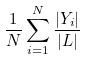Convert formula to latex. <formula><loc_0><loc_0><loc_500><loc_500>\frac { 1 } { N } \sum _ { i = 1 } ^ { N } \frac { | Y _ { i } | } { | L | }</formula> 